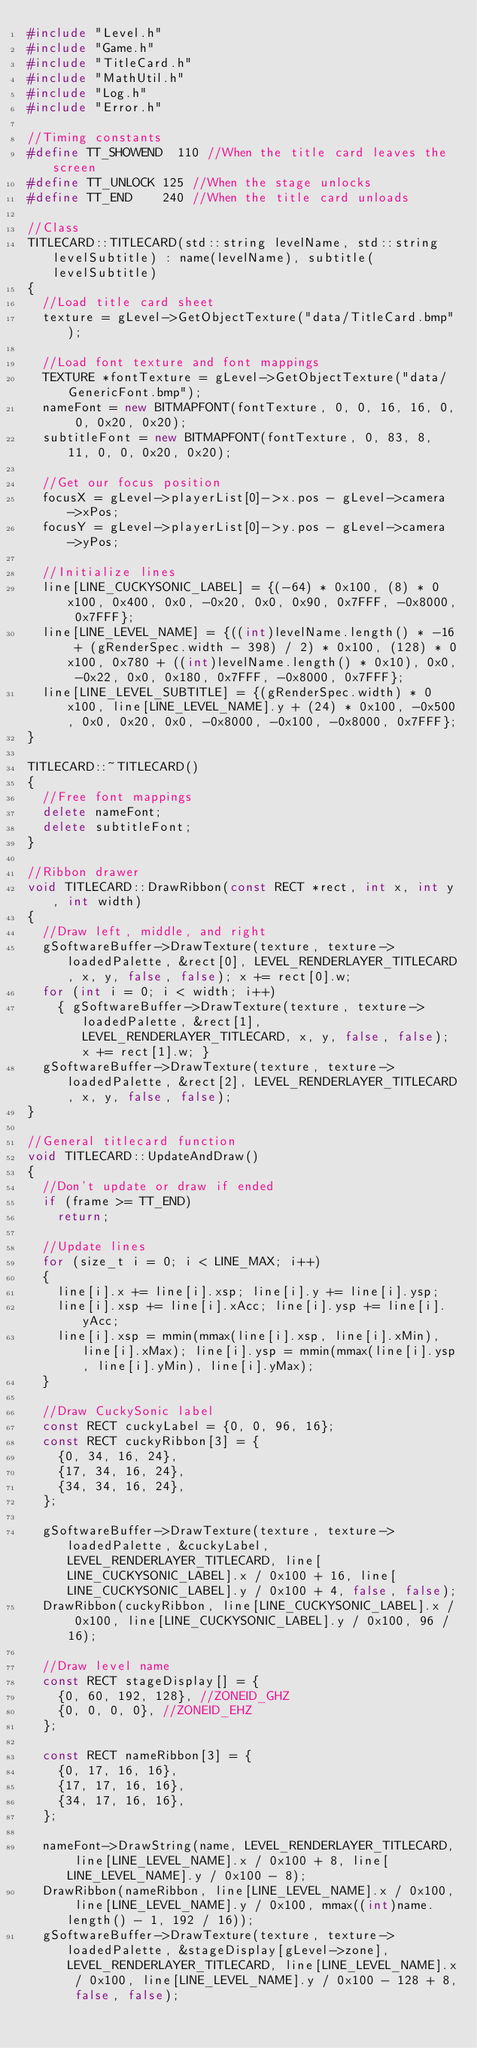<code> <loc_0><loc_0><loc_500><loc_500><_C++_>#include "Level.h"
#include "Game.h"
#include "TitleCard.h"
#include "MathUtil.h"
#include "Log.h"
#include "Error.h"

//Timing constants
#define TT_SHOWEND	110 //When the title card leaves the screen
#define TT_UNLOCK	125 //When the stage unlocks
#define TT_END		240 //When the title card unloads

//Class
TITLECARD::TITLECARD(std::string levelName, std::string levelSubtitle) : name(levelName), subtitle(levelSubtitle)
{
	//Load title card sheet
	texture = gLevel->GetObjectTexture("data/TitleCard.bmp");
	
	//Load font texture and font mappings
	TEXTURE *fontTexture = gLevel->GetObjectTexture("data/GenericFont.bmp");
	nameFont = new BITMAPFONT(fontTexture, 0, 0, 16, 16, 0, 0, 0x20, 0x20);
	subtitleFont = new BITMAPFONT(fontTexture, 0, 83, 8, 11, 0, 0, 0x20, 0x20);
	
	//Get our focus position
	focusX = gLevel->playerList[0]->x.pos - gLevel->camera->xPos;
	focusY = gLevel->playerList[0]->y.pos - gLevel->camera->yPos;
	
	//Initialize lines
	line[LINE_CUCKYSONIC_LABEL] = {(-64) * 0x100, (8) * 0x100, 0x400, 0x0, -0x20, 0x0, 0x90, 0x7FFF, -0x8000, 0x7FFF};
	line[LINE_LEVEL_NAME] = {((int)levelName.length() * -16 + (gRenderSpec.width - 398) / 2) * 0x100, (128) * 0x100, 0x780 + ((int)levelName.length() * 0x10), 0x0, -0x22, 0x0, 0x180, 0x7FFF, -0x8000, 0x7FFF};
	line[LINE_LEVEL_SUBTITLE] = {(gRenderSpec.width) * 0x100, line[LINE_LEVEL_NAME].y + (24) * 0x100, -0x500, 0x0, 0x20, 0x0, -0x8000, -0x100, -0x8000, 0x7FFF};
}

TITLECARD::~TITLECARD()
{
	//Free font mappings
	delete nameFont;
	delete subtitleFont;
}

//Ribbon drawer
void TITLECARD::DrawRibbon(const RECT *rect, int x, int y, int width)
{
	//Draw left, middle, and right
	gSoftwareBuffer->DrawTexture(texture, texture->loadedPalette, &rect[0], LEVEL_RENDERLAYER_TITLECARD, x, y, false, false); x += rect[0].w;
	for (int i = 0; i < width; i++)
		{ gSoftwareBuffer->DrawTexture(texture, texture->loadedPalette, &rect[1], LEVEL_RENDERLAYER_TITLECARD, x, y, false, false); x += rect[1].w; }
	gSoftwareBuffer->DrawTexture(texture, texture->loadedPalette, &rect[2], LEVEL_RENDERLAYER_TITLECARD, x, y, false, false);
}

//General titlecard function
void TITLECARD::UpdateAndDraw()
{
	//Don't update or draw if ended
	if (frame >= TT_END)
		return;
	
	//Update lines
	for (size_t i = 0; i < LINE_MAX; i++)
	{
		line[i].x += line[i].xsp; line[i].y += line[i].ysp;
		line[i].xsp += line[i].xAcc; line[i].ysp += line[i].yAcc;
		line[i].xsp = mmin(mmax(line[i].xsp, line[i].xMin), line[i].xMax); line[i].ysp = mmin(mmax(line[i].ysp, line[i].yMin), line[i].yMax);
	}
	
	//Draw CuckySonic label
	const RECT cuckyLabel = {0, 0, 96, 16};
	const RECT cuckyRibbon[3] = {
		{0, 34, 16, 24},
		{17, 34, 16, 24},
		{34, 34, 16, 24},
	};
	
	gSoftwareBuffer->DrawTexture(texture, texture->loadedPalette, &cuckyLabel, LEVEL_RENDERLAYER_TITLECARD, line[LINE_CUCKYSONIC_LABEL].x / 0x100 + 16, line[LINE_CUCKYSONIC_LABEL].y / 0x100 + 4, false, false);
	DrawRibbon(cuckyRibbon, line[LINE_CUCKYSONIC_LABEL].x / 0x100, line[LINE_CUCKYSONIC_LABEL].y / 0x100, 96 / 16);
	
	//Draw level name
	const RECT stageDisplay[] = {
		{0, 60, 192, 128}, //ZONEID_GHZ
		{0, 0, 0, 0}, //ZONEID_EHZ
	};
	
	const RECT nameRibbon[3] = {
		{0, 17, 16, 16},
		{17, 17, 16, 16},
		{34, 17, 16, 16},
	};
	
	nameFont->DrawString(name, LEVEL_RENDERLAYER_TITLECARD, line[LINE_LEVEL_NAME].x / 0x100 + 8, line[LINE_LEVEL_NAME].y / 0x100 - 8);
	DrawRibbon(nameRibbon, line[LINE_LEVEL_NAME].x / 0x100, line[LINE_LEVEL_NAME].y / 0x100, mmax((int)name.length() - 1, 192 / 16));
	gSoftwareBuffer->DrawTexture(texture, texture->loadedPalette, &stageDisplay[gLevel->zone], LEVEL_RENDERLAYER_TITLECARD, line[LINE_LEVEL_NAME].x / 0x100, line[LINE_LEVEL_NAME].y / 0x100 - 128 + 8, false, false);
	</code> 